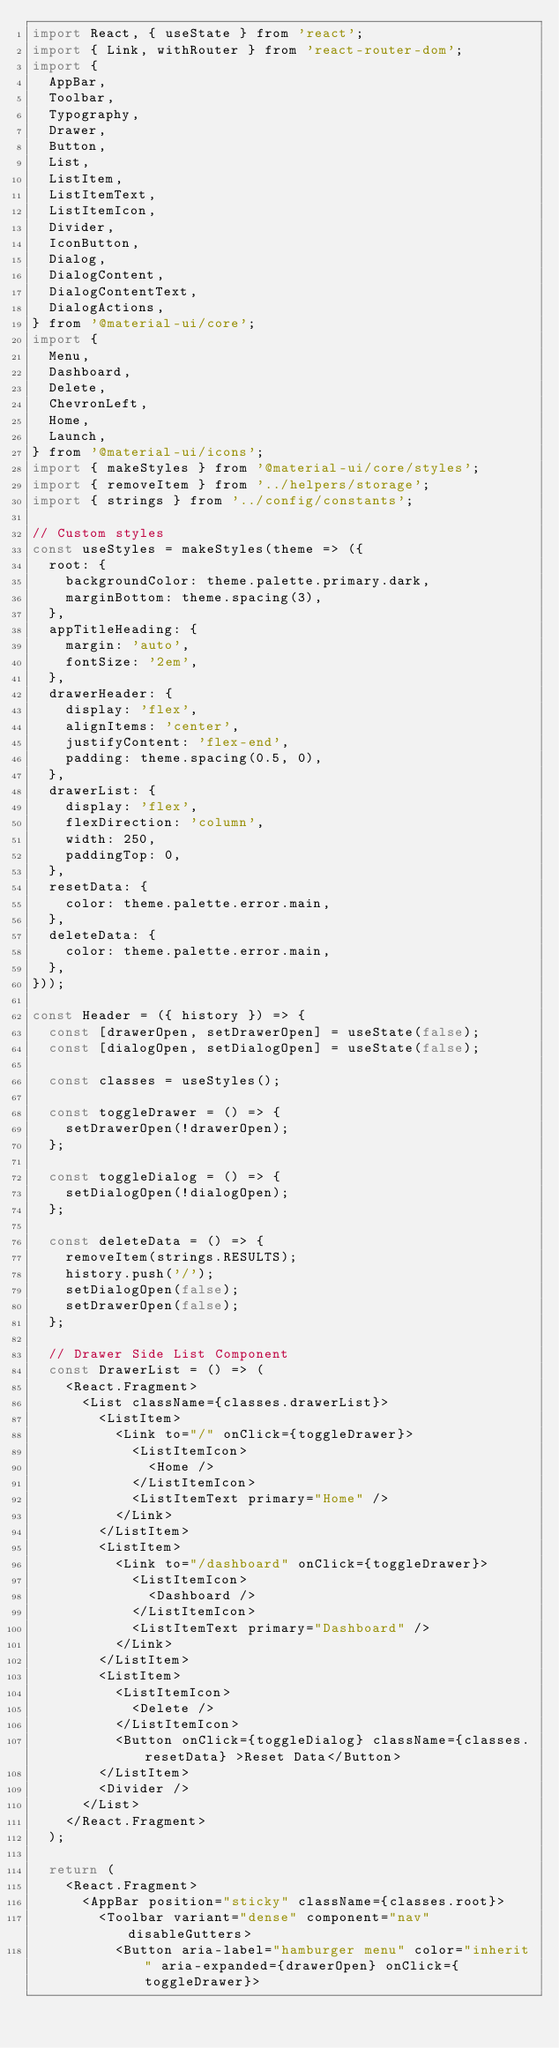Convert code to text. <code><loc_0><loc_0><loc_500><loc_500><_JavaScript_>import React, { useState } from 'react';
import { Link, withRouter } from 'react-router-dom';
import {
  AppBar,
  Toolbar,
  Typography,
  Drawer,
  Button,
  List,
  ListItem,
  ListItemText,
  ListItemIcon,
  Divider,
  IconButton,
  Dialog,
  DialogContent,
  DialogContentText,
  DialogActions,
} from '@material-ui/core';
import {
  Menu,
  Dashboard,
  Delete,
  ChevronLeft,
  Home,
  Launch,
} from '@material-ui/icons';
import { makeStyles } from '@material-ui/core/styles';
import { removeItem } from '../helpers/storage';
import { strings } from '../config/constants';

// Custom styles
const useStyles = makeStyles(theme => ({
  root: {
    backgroundColor: theme.palette.primary.dark,
    marginBottom: theme.spacing(3),
  },
  appTitleHeading: {
    margin: 'auto',
    fontSize: '2em',
  },
  drawerHeader: {
    display: 'flex',
    alignItems: 'center',
    justifyContent: 'flex-end',
    padding: theme.spacing(0.5, 0),
  },
  drawerList: {
    display: 'flex',
    flexDirection: 'column',
    width: 250,
    paddingTop: 0,
  },
  resetData: {
    color: theme.palette.error.main,
  },
  deleteData: {
    color: theme.palette.error.main,
  },
}));

const Header = ({ history }) => {
  const [drawerOpen, setDrawerOpen] = useState(false);
  const [dialogOpen, setDialogOpen] = useState(false);

  const classes = useStyles();

  const toggleDrawer = () => {
    setDrawerOpen(!drawerOpen);
  };

  const toggleDialog = () => {
    setDialogOpen(!dialogOpen);
  };

  const deleteData = () => {
    removeItem(strings.RESULTS);
    history.push('/');
    setDialogOpen(false);
    setDrawerOpen(false);
  };

  // Drawer Side List Component
  const DrawerList = () => (
    <React.Fragment>
      <List className={classes.drawerList}>
        <ListItem>
          <Link to="/" onClick={toggleDrawer}>
            <ListItemIcon>
              <Home />
            </ListItemIcon>
            <ListItemText primary="Home" />
          </Link>
        </ListItem>
        <ListItem>
          <Link to="/dashboard" onClick={toggleDrawer}>
            <ListItemIcon>
              <Dashboard />
            </ListItemIcon>
            <ListItemText primary="Dashboard" />
          </Link>
        </ListItem>
        <ListItem>
          <ListItemIcon>
            <Delete />
          </ListItemIcon>
          <Button onClick={toggleDialog} className={classes.resetData} >Reset Data</Button>
        </ListItem>
        <Divider />
      </List>
    </React.Fragment>
  );

  return (
    <React.Fragment>
      <AppBar position="sticky" className={classes.root}>
        <Toolbar variant="dense" component="nav" disableGutters>
          <Button aria-label="hamburger menu" color="inherit" aria-expanded={drawerOpen} onClick={toggleDrawer}></code> 